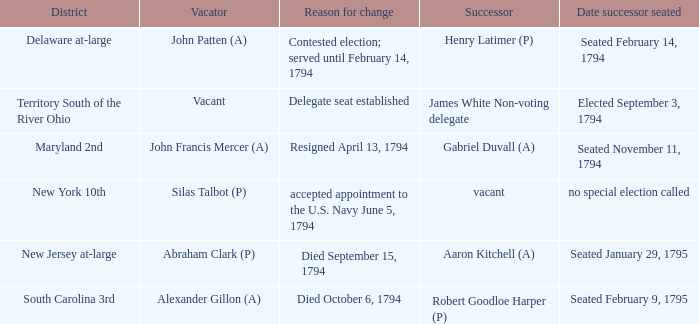Identify the date successor took office in south carolina's 3rd district. Seated February 9, 1795. 